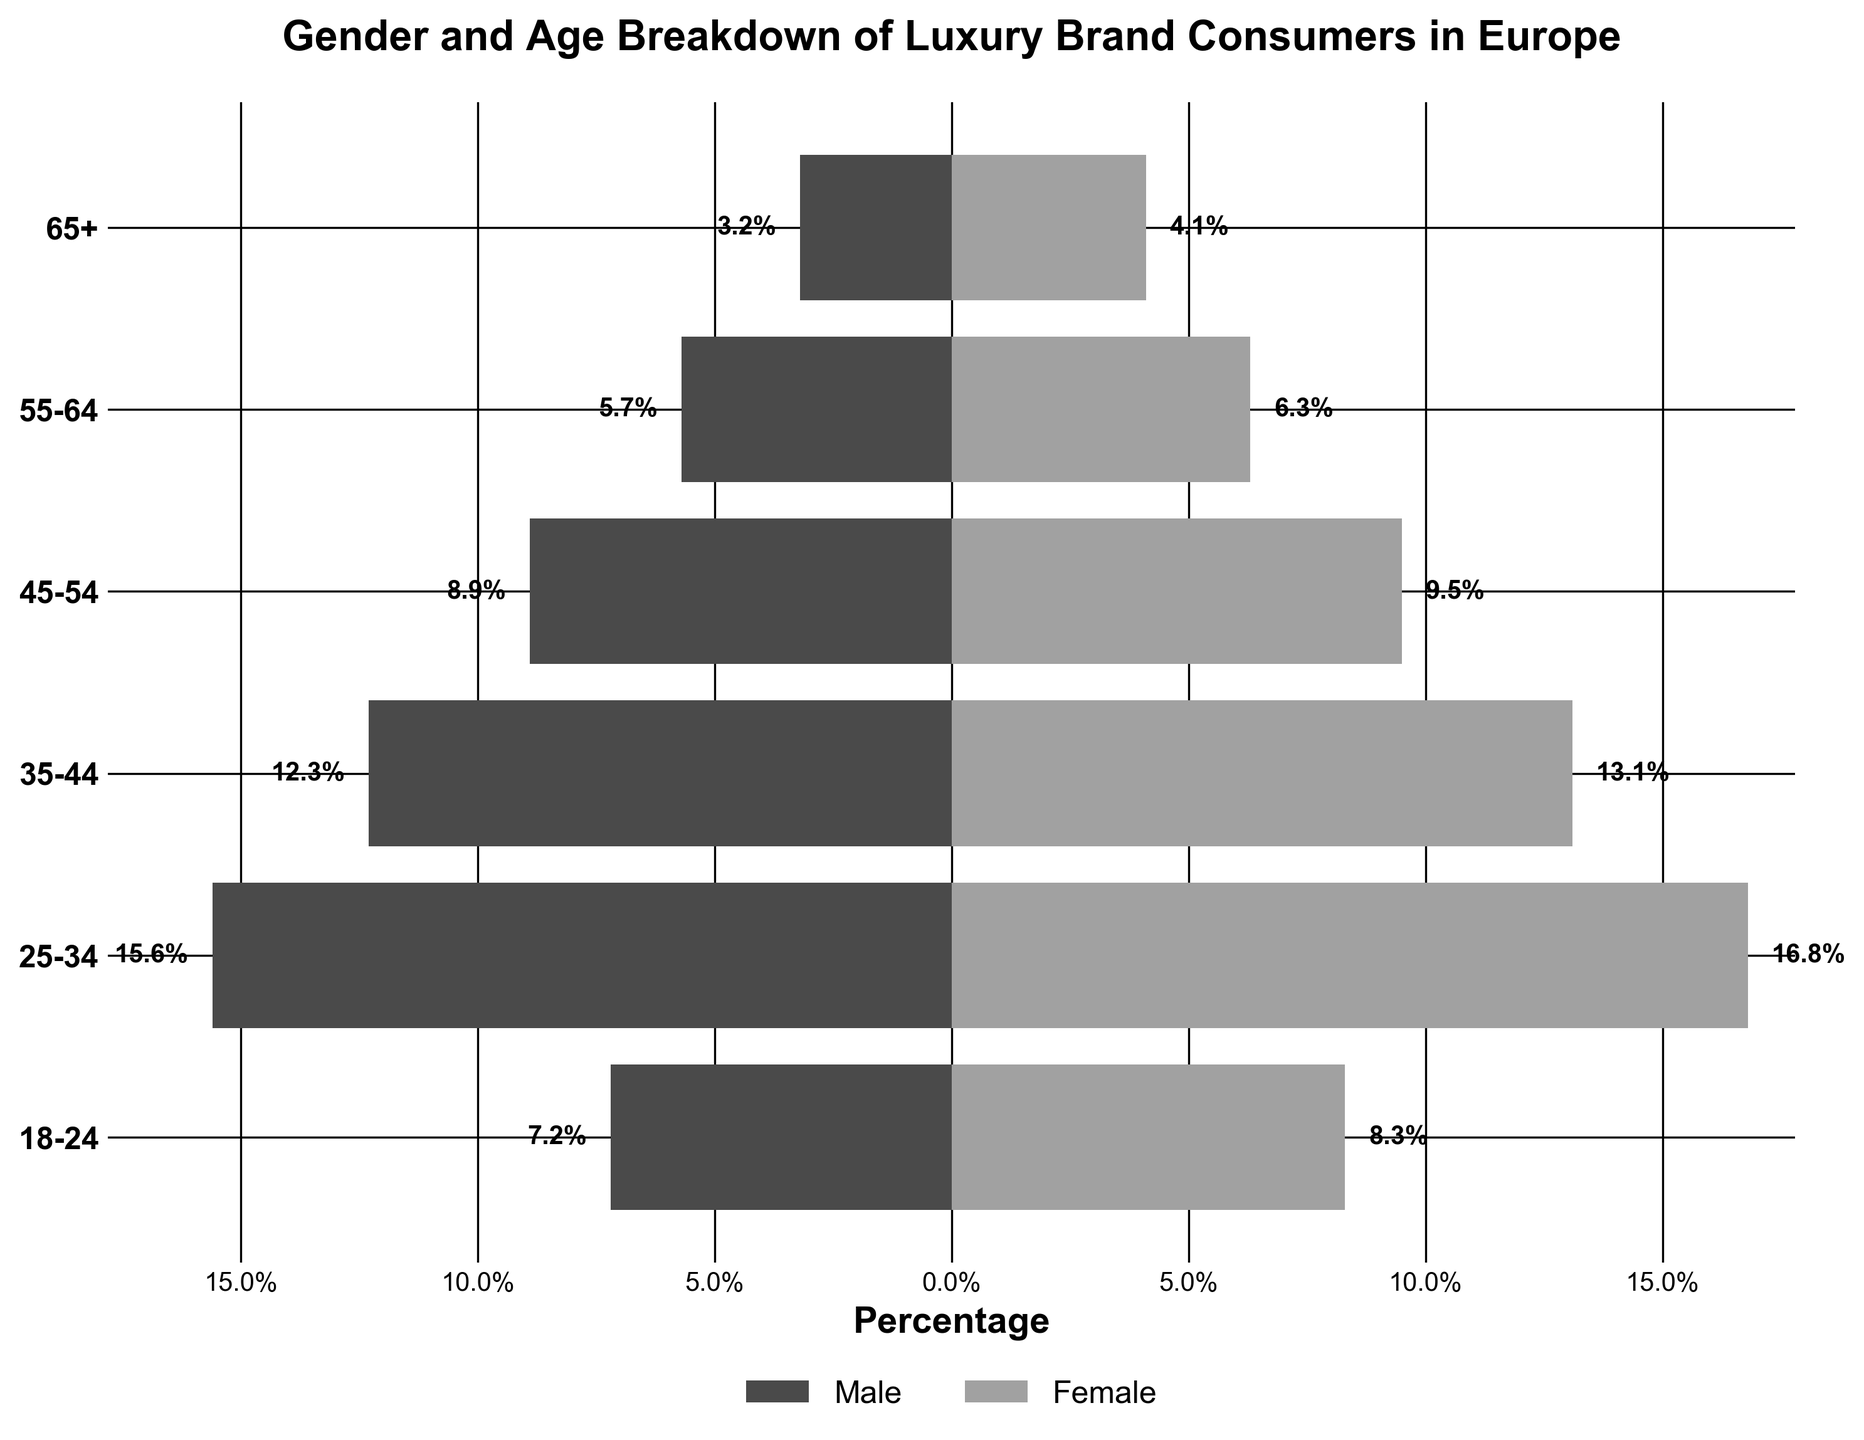What is the title of the chart? The title can be read directly from the top of the chart, which provides an immediate summary of the data being visualized.
Answer: "Gender and Age Breakdown of Luxury Brand Consumers in Europe" Which gender has a higher percentage in the 25-34 age group? Compare the bar lengths for males and females in the 25-34 age group; the female bar is longer.
Answer: Female What is the percentage of male consumers in the 45-54 age group? Locate the male bar for the 45-54 age group and read the percentage value next to it.
Answer: 8.9% How does the percentage of female consumers in the 55-64 age group compare to that of male consumers? Compare the lengths of the bars for females and males in the 55-64 age group; the female bar is slightly longer.
Answer: Female percentage is higher What is the total percentage of luxury brand consumers in the 18-24 age group? Sum the male and female percentages for the 18-24 age group: 7.2% (male) + 8.3% (female) = 15.5%.
Answer: 15.5% Which age group has the highest percentage of male consumers? Identify the longest male bar and note the age group it corresponds to; it is the 25-34 age group.
Answer: 25-34 What is the difference in percentage between male and female consumers in the 35-44 age group? Subtract the male percentage from the female percentage for the 35-44 age group: 13.1% (female) - 12.3% (male) = 0.8%.
Answer: 0.8% Which age group has the smallest gender gap in percentage among consumers? For each age group, calculate the absolute difference between male and female percentages, and identify the smallest difference; it is the 65+ age group.
Answer: 65+ What is the average percentage of female consumers across all age groups? Sum the female percentages and divide by the number of age groups: (4.1% + 6.3% + 9.5% + 13.1% + 16.8% + 8.3%) / 6 = 9.68%.
Answer: 9.68% Is the percentage of male consumers over 55 higher or lower than the percentage of female consumers under 25? Sum the male percentages for age groups 55-64 and 65+: 5.7% + 3.2% = 8.9%. Compare it to the female percentage for the 18-24 age group, which is 8.3%; 8.9% > 8.3%.
Answer: Higher 